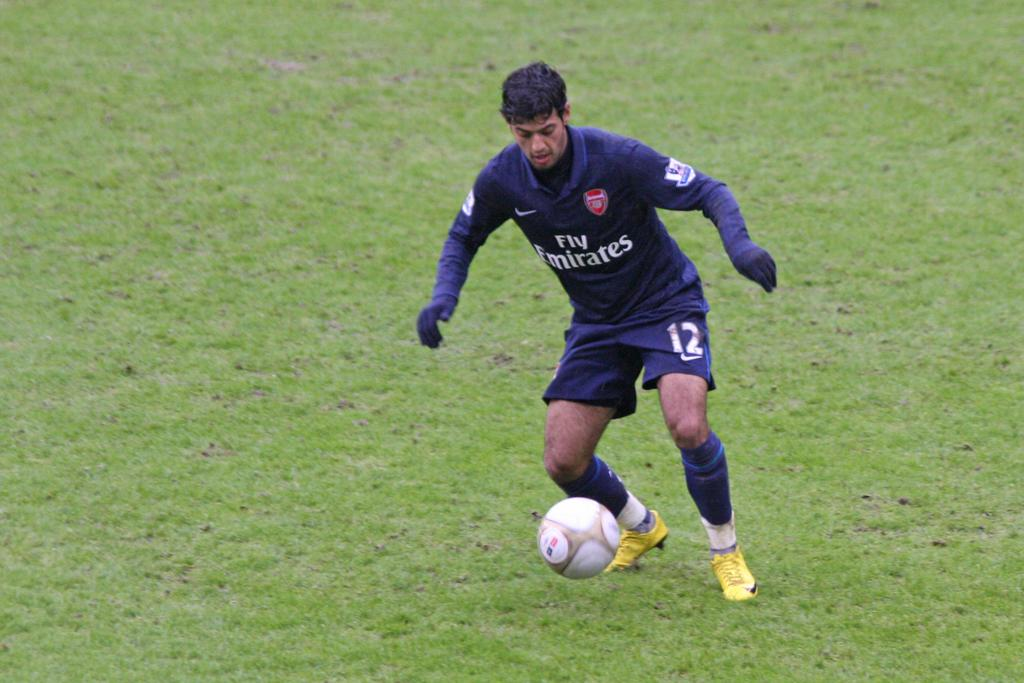What is the man in the image doing? The man is playing with a football in the image. What is the surface on which the football is placed? The football is on grass. What color is the man's shirt? The man's shirt is blue. What type of gloves is the man wearing? The man is wearing blue gloves. What type of fish can be seen swimming in the water near the man? There is no water or fish present in the image; it features a man playing with a football on grass. 